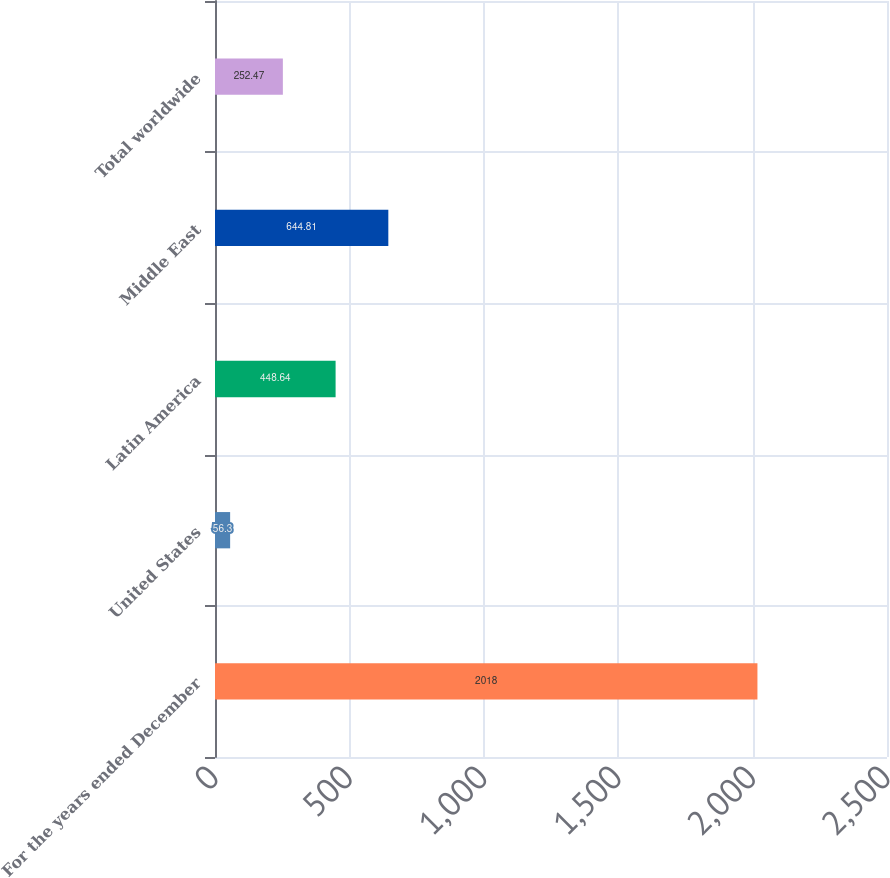Convert chart. <chart><loc_0><loc_0><loc_500><loc_500><bar_chart><fcel>For the years ended December<fcel>United States<fcel>Latin America<fcel>Middle East<fcel>Total worldwide<nl><fcel>2018<fcel>56.3<fcel>448.64<fcel>644.81<fcel>252.47<nl></chart> 